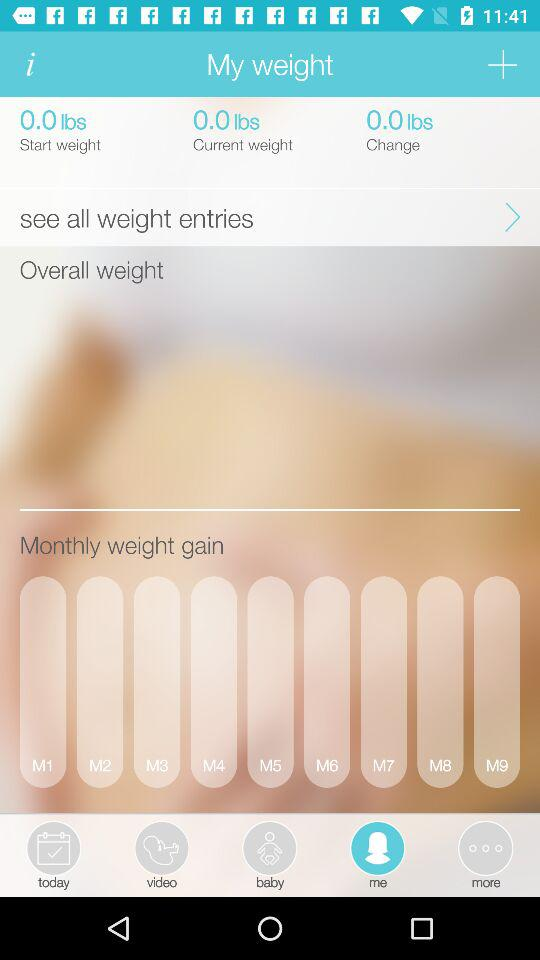What is the current weight? The current weight is 0.0 lbs. 